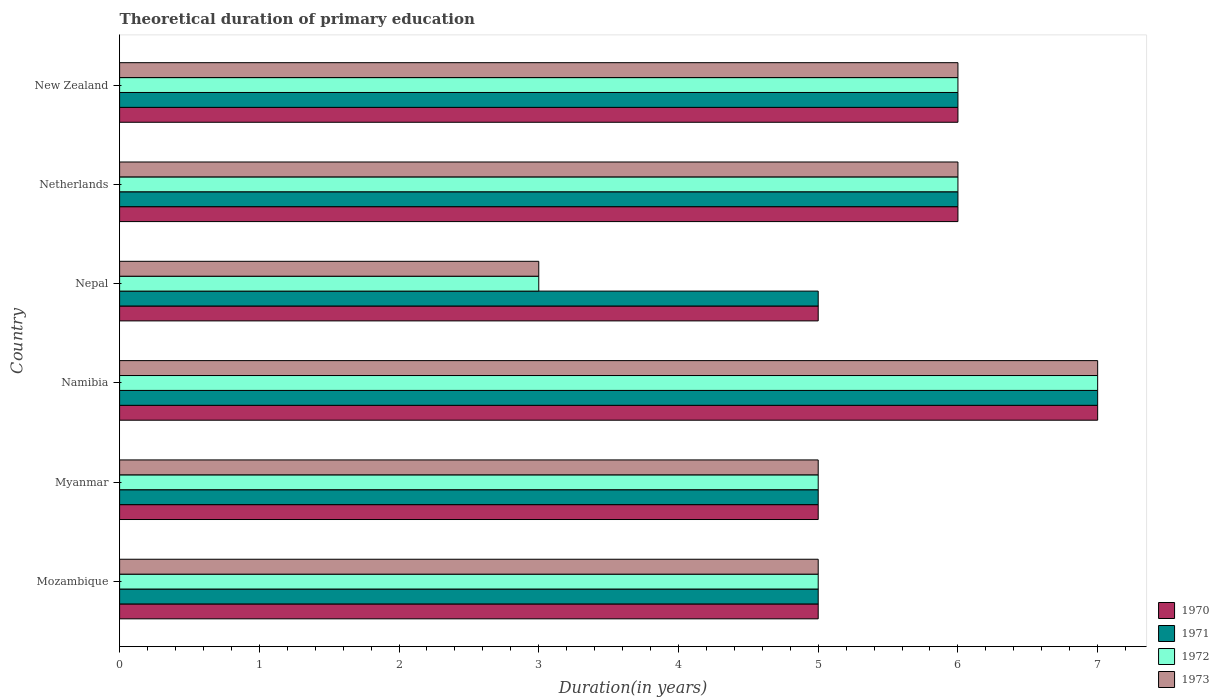How many different coloured bars are there?
Keep it short and to the point. 4. How many groups of bars are there?
Make the answer very short. 6. What is the label of the 6th group of bars from the top?
Provide a succinct answer. Mozambique. In how many cases, is the number of bars for a given country not equal to the number of legend labels?
Keep it short and to the point. 0. Across all countries, what is the maximum total theoretical duration of primary education in 1970?
Offer a terse response. 7. In which country was the total theoretical duration of primary education in 1972 maximum?
Ensure brevity in your answer.  Namibia. In which country was the total theoretical duration of primary education in 1973 minimum?
Provide a short and direct response. Nepal. What is the total total theoretical duration of primary education in 1973 in the graph?
Give a very brief answer. 32. What is the difference between the total theoretical duration of primary education in 1971 in Mozambique and that in New Zealand?
Your response must be concise. -1. What is the average total theoretical duration of primary education in 1972 per country?
Offer a very short reply. 5.33. What is the ratio of the total theoretical duration of primary education in 1970 in Mozambique to that in New Zealand?
Provide a succinct answer. 0.83. Is the difference between the total theoretical duration of primary education in 1972 in Nepal and New Zealand greater than the difference between the total theoretical duration of primary education in 1971 in Nepal and New Zealand?
Provide a short and direct response. No. What is the difference between the highest and the second highest total theoretical duration of primary education in 1971?
Provide a succinct answer. 1. In how many countries, is the total theoretical duration of primary education in 1970 greater than the average total theoretical duration of primary education in 1970 taken over all countries?
Provide a short and direct response. 3. What does the 1st bar from the top in Myanmar represents?
Provide a succinct answer. 1973. What does the 1st bar from the bottom in Namibia represents?
Offer a very short reply. 1970. How many bars are there?
Provide a short and direct response. 24. Are all the bars in the graph horizontal?
Keep it short and to the point. Yes. What is the difference between two consecutive major ticks on the X-axis?
Your answer should be very brief. 1. Are the values on the major ticks of X-axis written in scientific E-notation?
Ensure brevity in your answer.  No. What is the title of the graph?
Offer a terse response. Theoretical duration of primary education. What is the label or title of the X-axis?
Make the answer very short. Duration(in years). What is the label or title of the Y-axis?
Provide a short and direct response. Country. What is the Duration(in years) of 1970 in Mozambique?
Provide a short and direct response. 5. What is the Duration(in years) in 1972 in Mozambique?
Your response must be concise. 5. What is the Duration(in years) of 1973 in Mozambique?
Offer a terse response. 5. What is the Duration(in years) of 1973 in Myanmar?
Keep it short and to the point. 5. What is the Duration(in years) of 1970 in Namibia?
Your response must be concise. 7. What is the Duration(in years) of 1971 in Namibia?
Your response must be concise. 7. What is the Duration(in years) in 1970 in Nepal?
Ensure brevity in your answer.  5. What is the Duration(in years) of 1973 in Nepal?
Offer a terse response. 3. What is the Duration(in years) of 1970 in Netherlands?
Make the answer very short. 6. Across all countries, what is the maximum Duration(in years) of 1972?
Provide a succinct answer. 7. Across all countries, what is the maximum Duration(in years) of 1973?
Keep it short and to the point. 7. Across all countries, what is the minimum Duration(in years) in 1970?
Keep it short and to the point. 5. Across all countries, what is the minimum Duration(in years) in 1971?
Your answer should be very brief. 5. Across all countries, what is the minimum Duration(in years) in 1972?
Ensure brevity in your answer.  3. Across all countries, what is the minimum Duration(in years) of 1973?
Provide a short and direct response. 3. What is the total Duration(in years) in 1970 in the graph?
Make the answer very short. 34. What is the total Duration(in years) in 1973 in the graph?
Keep it short and to the point. 32. What is the difference between the Duration(in years) in 1971 in Mozambique and that in Myanmar?
Offer a terse response. 0. What is the difference between the Duration(in years) of 1972 in Mozambique and that in Myanmar?
Provide a short and direct response. 0. What is the difference between the Duration(in years) of 1970 in Mozambique and that in Namibia?
Provide a short and direct response. -2. What is the difference between the Duration(in years) of 1970 in Mozambique and that in Nepal?
Your answer should be very brief. 0. What is the difference between the Duration(in years) in 1971 in Mozambique and that in Netherlands?
Your answer should be very brief. -1. What is the difference between the Duration(in years) in 1973 in Mozambique and that in Netherlands?
Provide a short and direct response. -1. What is the difference between the Duration(in years) of 1973 in Mozambique and that in New Zealand?
Your response must be concise. -1. What is the difference between the Duration(in years) in 1972 in Myanmar and that in Namibia?
Give a very brief answer. -2. What is the difference between the Duration(in years) in 1970 in Myanmar and that in Nepal?
Your answer should be very brief. 0. What is the difference between the Duration(in years) of 1971 in Myanmar and that in Nepal?
Offer a terse response. 0. What is the difference between the Duration(in years) in 1972 in Myanmar and that in Netherlands?
Provide a succinct answer. -1. What is the difference between the Duration(in years) in 1973 in Myanmar and that in Netherlands?
Provide a short and direct response. -1. What is the difference between the Duration(in years) of 1971 in Myanmar and that in New Zealand?
Offer a very short reply. -1. What is the difference between the Duration(in years) of 1972 in Myanmar and that in New Zealand?
Offer a terse response. -1. What is the difference between the Duration(in years) of 1973 in Myanmar and that in New Zealand?
Give a very brief answer. -1. What is the difference between the Duration(in years) in 1970 in Namibia and that in Nepal?
Offer a very short reply. 2. What is the difference between the Duration(in years) in 1973 in Namibia and that in Nepal?
Provide a succinct answer. 4. What is the difference between the Duration(in years) of 1973 in Namibia and that in Netherlands?
Your response must be concise. 1. What is the difference between the Duration(in years) of 1971 in Nepal and that in Netherlands?
Keep it short and to the point. -1. What is the difference between the Duration(in years) in 1972 in Nepal and that in Netherlands?
Your answer should be compact. -3. What is the difference between the Duration(in years) of 1970 in Nepal and that in New Zealand?
Offer a terse response. -1. What is the difference between the Duration(in years) of 1971 in Nepal and that in New Zealand?
Offer a terse response. -1. What is the difference between the Duration(in years) of 1972 in Nepal and that in New Zealand?
Keep it short and to the point. -3. What is the difference between the Duration(in years) in 1970 in Netherlands and that in New Zealand?
Make the answer very short. 0. What is the difference between the Duration(in years) in 1973 in Netherlands and that in New Zealand?
Your answer should be very brief. 0. What is the difference between the Duration(in years) of 1970 in Mozambique and the Duration(in years) of 1971 in Myanmar?
Ensure brevity in your answer.  0. What is the difference between the Duration(in years) of 1970 in Mozambique and the Duration(in years) of 1973 in Myanmar?
Your answer should be very brief. 0. What is the difference between the Duration(in years) in 1972 in Mozambique and the Duration(in years) in 1973 in Myanmar?
Your answer should be compact. 0. What is the difference between the Duration(in years) of 1970 in Mozambique and the Duration(in years) of 1971 in Namibia?
Your answer should be very brief. -2. What is the difference between the Duration(in years) in 1971 in Mozambique and the Duration(in years) in 1972 in Namibia?
Your response must be concise. -2. What is the difference between the Duration(in years) of 1971 in Mozambique and the Duration(in years) of 1973 in Namibia?
Ensure brevity in your answer.  -2. What is the difference between the Duration(in years) of 1970 in Mozambique and the Duration(in years) of 1973 in Nepal?
Your answer should be very brief. 2. What is the difference between the Duration(in years) of 1971 in Mozambique and the Duration(in years) of 1973 in Nepal?
Offer a terse response. 2. What is the difference between the Duration(in years) of 1970 in Mozambique and the Duration(in years) of 1971 in Netherlands?
Your response must be concise. -1. What is the difference between the Duration(in years) in 1971 in Mozambique and the Duration(in years) in 1972 in Netherlands?
Provide a short and direct response. -1. What is the difference between the Duration(in years) of 1972 in Mozambique and the Duration(in years) of 1973 in Netherlands?
Give a very brief answer. -1. What is the difference between the Duration(in years) in 1970 in Mozambique and the Duration(in years) in 1972 in New Zealand?
Provide a short and direct response. -1. What is the difference between the Duration(in years) in 1970 in Mozambique and the Duration(in years) in 1973 in New Zealand?
Give a very brief answer. -1. What is the difference between the Duration(in years) of 1971 in Mozambique and the Duration(in years) of 1973 in New Zealand?
Keep it short and to the point. -1. What is the difference between the Duration(in years) of 1972 in Mozambique and the Duration(in years) of 1973 in New Zealand?
Make the answer very short. -1. What is the difference between the Duration(in years) of 1970 in Myanmar and the Duration(in years) of 1973 in Namibia?
Provide a short and direct response. -2. What is the difference between the Duration(in years) of 1971 in Myanmar and the Duration(in years) of 1972 in Namibia?
Ensure brevity in your answer.  -2. What is the difference between the Duration(in years) in 1970 in Myanmar and the Duration(in years) in 1971 in Nepal?
Offer a terse response. 0. What is the difference between the Duration(in years) in 1971 in Myanmar and the Duration(in years) in 1972 in Nepal?
Your response must be concise. 2. What is the difference between the Duration(in years) of 1971 in Myanmar and the Duration(in years) of 1973 in Nepal?
Provide a short and direct response. 2. What is the difference between the Duration(in years) of 1972 in Myanmar and the Duration(in years) of 1973 in Nepal?
Your answer should be very brief. 2. What is the difference between the Duration(in years) in 1970 in Myanmar and the Duration(in years) in 1971 in Netherlands?
Offer a terse response. -1. What is the difference between the Duration(in years) of 1970 in Myanmar and the Duration(in years) of 1973 in Netherlands?
Give a very brief answer. -1. What is the difference between the Duration(in years) in 1971 in Myanmar and the Duration(in years) in 1972 in Netherlands?
Provide a short and direct response. -1. What is the difference between the Duration(in years) in 1971 in Myanmar and the Duration(in years) in 1973 in Netherlands?
Provide a succinct answer. -1. What is the difference between the Duration(in years) in 1970 in Myanmar and the Duration(in years) in 1971 in New Zealand?
Offer a very short reply. -1. What is the difference between the Duration(in years) of 1970 in Myanmar and the Duration(in years) of 1972 in New Zealand?
Keep it short and to the point. -1. What is the difference between the Duration(in years) in 1970 in Myanmar and the Duration(in years) in 1973 in New Zealand?
Your answer should be compact. -1. What is the difference between the Duration(in years) of 1972 in Myanmar and the Duration(in years) of 1973 in New Zealand?
Make the answer very short. -1. What is the difference between the Duration(in years) of 1970 in Namibia and the Duration(in years) of 1971 in Nepal?
Give a very brief answer. 2. What is the difference between the Duration(in years) in 1970 in Namibia and the Duration(in years) in 1972 in Nepal?
Provide a succinct answer. 4. What is the difference between the Duration(in years) of 1971 in Namibia and the Duration(in years) of 1973 in Nepal?
Make the answer very short. 4. What is the difference between the Duration(in years) in 1972 in Namibia and the Duration(in years) in 1973 in Nepal?
Your answer should be compact. 4. What is the difference between the Duration(in years) in 1970 in Namibia and the Duration(in years) in 1972 in Netherlands?
Your answer should be very brief. 1. What is the difference between the Duration(in years) of 1971 in Namibia and the Duration(in years) of 1973 in Netherlands?
Your answer should be very brief. 1. What is the difference between the Duration(in years) in 1970 in Namibia and the Duration(in years) in 1971 in New Zealand?
Keep it short and to the point. 1. What is the difference between the Duration(in years) of 1971 in Namibia and the Duration(in years) of 1972 in New Zealand?
Offer a terse response. 1. What is the difference between the Duration(in years) in 1972 in Namibia and the Duration(in years) in 1973 in New Zealand?
Provide a short and direct response. 1. What is the difference between the Duration(in years) of 1971 in Nepal and the Duration(in years) of 1972 in Netherlands?
Your response must be concise. -1. What is the difference between the Duration(in years) of 1971 in Nepal and the Duration(in years) of 1973 in Netherlands?
Provide a short and direct response. -1. What is the difference between the Duration(in years) in 1970 in Nepal and the Duration(in years) in 1972 in New Zealand?
Offer a terse response. -1. What is the difference between the Duration(in years) of 1970 in Nepal and the Duration(in years) of 1973 in New Zealand?
Your response must be concise. -1. What is the difference between the Duration(in years) in 1971 in Nepal and the Duration(in years) in 1972 in New Zealand?
Your response must be concise. -1. What is the difference between the Duration(in years) of 1971 in Nepal and the Duration(in years) of 1973 in New Zealand?
Your answer should be compact. -1. What is the difference between the Duration(in years) of 1970 in Netherlands and the Duration(in years) of 1971 in New Zealand?
Give a very brief answer. 0. What is the difference between the Duration(in years) in 1970 in Netherlands and the Duration(in years) in 1973 in New Zealand?
Keep it short and to the point. 0. What is the difference between the Duration(in years) of 1971 in Netherlands and the Duration(in years) of 1972 in New Zealand?
Provide a short and direct response. 0. What is the difference between the Duration(in years) in 1972 in Netherlands and the Duration(in years) in 1973 in New Zealand?
Ensure brevity in your answer.  0. What is the average Duration(in years) of 1970 per country?
Make the answer very short. 5.67. What is the average Duration(in years) of 1971 per country?
Your response must be concise. 5.67. What is the average Duration(in years) of 1972 per country?
Your answer should be compact. 5.33. What is the average Duration(in years) of 1973 per country?
Your answer should be compact. 5.33. What is the difference between the Duration(in years) of 1970 and Duration(in years) of 1971 in Mozambique?
Offer a terse response. 0. What is the difference between the Duration(in years) of 1970 and Duration(in years) of 1973 in Mozambique?
Your answer should be very brief. 0. What is the difference between the Duration(in years) of 1971 and Duration(in years) of 1972 in Mozambique?
Your response must be concise. 0. What is the difference between the Duration(in years) in 1971 and Duration(in years) in 1973 in Mozambique?
Give a very brief answer. 0. What is the difference between the Duration(in years) in 1972 and Duration(in years) in 1973 in Mozambique?
Your answer should be compact. 0. What is the difference between the Duration(in years) of 1971 and Duration(in years) of 1973 in Myanmar?
Keep it short and to the point. 0. What is the difference between the Duration(in years) in 1972 and Duration(in years) in 1973 in Myanmar?
Provide a short and direct response. 0. What is the difference between the Duration(in years) of 1970 and Duration(in years) of 1973 in Namibia?
Provide a short and direct response. 0. What is the difference between the Duration(in years) in 1971 and Duration(in years) in 1972 in Namibia?
Your answer should be compact. 0. What is the difference between the Duration(in years) of 1970 and Duration(in years) of 1971 in Nepal?
Ensure brevity in your answer.  0. What is the difference between the Duration(in years) of 1970 and Duration(in years) of 1973 in Nepal?
Ensure brevity in your answer.  2. What is the difference between the Duration(in years) of 1971 and Duration(in years) of 1973 in Nepal?
Ensure brevity in your answer.  2. What is the difference between the Duration(in years) in 1970 and Duration(in years) in 1971 in Netherlands?
Give a very brief answer. 0. What is the difference between the Duration(in years) in 1970 and Duration(in years) in 1972 in Netherlands?
Offer a terse response. 0. What is the difference between the Duration(in years) in 1970 and Duration(in years) in 1973 in Netherlands?
Your answer should be very brief. 0. What is the difference between the Duration(in years) of 1971 and Duration(in years) of 1973 in Netherlands?
Provide a short and direct response. 0. What is the difference between the Duration(in years) in 1970 and Duration(in years) in 1972 in New Zealand?
Ensure brevity in your answer.  0. What is the difference between the Duration(in years) of 1971 and Duration(in years) of 1972 in New Zealand?
Your answer should be compact. 0. What is the difference between the Duration(in years) of 1971 and Duration(in years) of 1973 in New Zealand?
Your response must be concise. 0. What is the ratio of the Duration(in years) in 1970 in Mozambique to that in Myanmar?
Give a very brief answer. 1. What is the ratio of the Duration(in years) of 1973 in Mozambique to that in Myanmar?
Your answer should be very brief. 1. What is the ratio of the Duration(in years) of 1970 in Mozambique to that in Namibia?
Offer a terse response. 0.71. What is the ratio of the Duration(in years) of 1971 in Mozambique to that in Nepal?
Your answer should be very brief. 1. What is the ratio of the Duration(in years) of 1972 in Mozambique to that in Nepal?
Ensure brevity in your answer.  1.67. What is the ratio of the Duration(in years) in 1973 in Mozambique to that in Nepal?
Offer a very short reply. 1.67. What is the ratio of the Duration(in years) of 1971 in Mozambique to that in Netherlands?
Your answer should be very brief. 0.83. What is the ratio of the Duration(in years) in 1970 in Mozambique to that in New Zealand?
Offer a very short reply. 0.83. What is the ratio of the Duration(in years) in 1970 in Myanmar to that in Namibia?
Your answer should be compact. 0.71. What is the ratio of the Duration(in years) of 1972 in Myanmar to that in Nepal?
Make the answer very short. 1.67. What is the ratio of the Duration(in years) of 1973 in Myanmar to that in Nepal?
Offer a very short reply. 1.67. What is the ratio of the Duration(in years) of 1970 in Myanmar to that in Netherlands?
Give a very brief answer. 0.83. What is the ratio of the Duration(in years) of 1971 in Myanmar to that in Netherlands?
Give a very brief answer. 0.83. What is the ratio of the Duration(in years) of 1971 in Myanmar to that in New Zealand?
Keep it short and to the point. 0.83. What is the ratio of the Duration(in years) in 1972 in Myanmar to that in New Zealand?
Your answer should be compact. 0.83. What is the ratio of the Duration(in years) in 1971 in Namibia to that in Nepal?
Offer a very short reply. 1.4. What is the ratio of the Duration(in years) of 1972 in Namibia to that in Nepal?
Provide a short and direct response. 2.33. What is the ratio of the Duration(in years) in 1973 in Namibia to that in Nepal?
Provide a succinct answer. 2.33. What is the ratio of the Duration(in years) in 1971 in Namibia to that in Netherlands?
Offer a terse response. 1.17. What is the ratio of the Duration(in years) of 1972 in Namibia to that in Netherlands?
Ensure brevity in your answer.  1.17. What is the ratio of the Duration(in years) of 1972 in Namibia to that in New Zealand?
Give a very brief answer. 1.17. What is the ratio of the Duration(in years) in 1973 in Namibia to that in New Zealand?
Offer a very short reply. 1.17. What is the ratio of the Duration(in years) in 1970 in Nepal to that in Netherlands?
Your answer should be compact. 0.83. What is the ratio of the Duration(in years) in 1973 in Nepal to that in Netherlands?
Your answer should be compact. 0.5. What is the ratio of the Duration(in years) of 1973 in Nepal to that in New Zealand?
Offer a very short reply. 0.5. What is the ratio of the Duration(in years) of 1970 in Netherlands to that in New Zealand?
Your answer should be compact. 1. What is the ratio of the Duration(in years) in 1971 in Netherlands to that in New Zealand?
Offer a very short reply. 1. What is the ratio of the Duration(in years) in 1972 in Netherlands to that in New Zealand?
Your answer should be compact. 1. What is the ratio of the Duration(in years) of 1973 in Netherlands to that in New Zealand?
Make the answer very short. 1. What is the difference between the highest and the second highest Duration(in years) in 1970?
Give a very brief answer. 1. What is the difference between the highest and the lowest Duration(in years) in 1970?
Provide a succinct answer. 2. What is the difference between the highest and the lowest Duration(in years) of 1972?
Give a very brief answer. 4. What is the difference between the highest and the lowest Duration(in years) in 1973?
Keep it short and to the point. 4. 